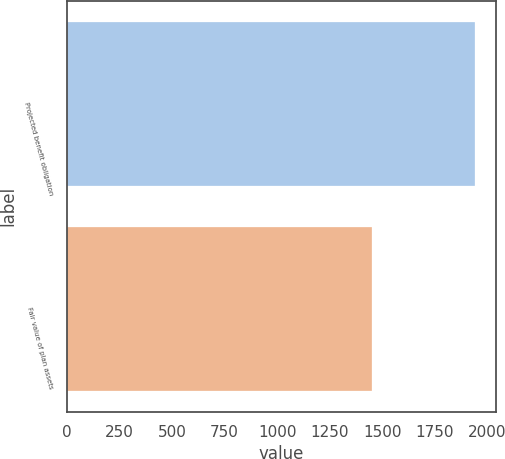Convert chart to OTSL. <chart><loc_0><loc_0><loc_500><loc_500><bar_chart><fcel>Projected benefit obligation<fcel>Fair value of plan assets<nl><fcel>1941.9<fcel>1449.5<nl></chart> 